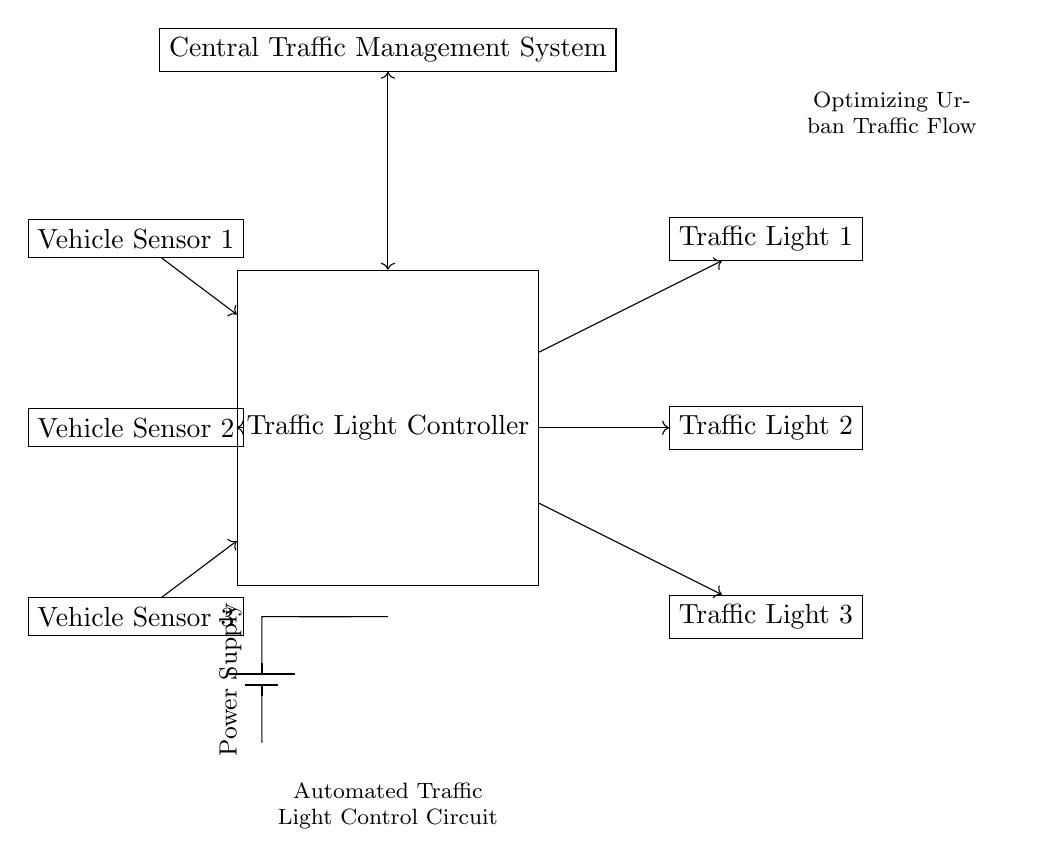What are the three components in this circuit? The circuit contains a Traffic Light Controller, three Vehicle Sensors, and three Traffic Lights. Each component plays a role in regulating traffic based on vehicle presence.
Answer: Traffic Light Controller, Vehicle Sensors, Traffic Lights How many Vehicle Sensors are there? The diagram shows three distinct Vehicle Sensors labeled as Vehicle Sensor 1, Vehicle Sensor 2, and Vehicle Sensor 3. Each sensor detects vehicles approaching the traffic light.
Answer: Three What connects the Vehicle Sensors to the Traffic Light Controller? The connections are depicted with arrows indicating a one-way flow of information from each Vehicle Sensor to the Traffic Light Controller, implying that the sensors provide vehicle detection data to the controller.
Answer: Arrows What is the purpose of the Central Traffic Management System? The Central Traffic Management System is shown connected to the Traffic Light Controller with a bidirectional arrow, suggesting it communicates and manages overall traffic signals across multiple intersections, optimizing urban traffic flow more effectively.
Answer: Management Describe the direction of flow between the Traffic Light Controller and the Traffic Lights. The flow is unidirectional, as indicated by arrows moving from the Traffic Light Controller to each Traffic Light, signifying that the controller sends commands to change the light statuses based on sensor input.
Answer: Unidirectional What is the power supply for this circuit? The circuit includes a Power Supply indicated by a battery symbol connected to the Traffic Light Controller, providing the necessary electrical energy for functioning without specifying voltage values.
Answer: Battery What does the phrase at the bottom indicate about the circuit's goal? The phrase "Optimizing Urban Traffic Flow" reflects the main objective of the automated traffic light control circuit, which is to improve traffic efficiency and reduce congestion in urban environments by smartly managing traffic light signals.
Answer: Optimizing Urban Traffic Flow 